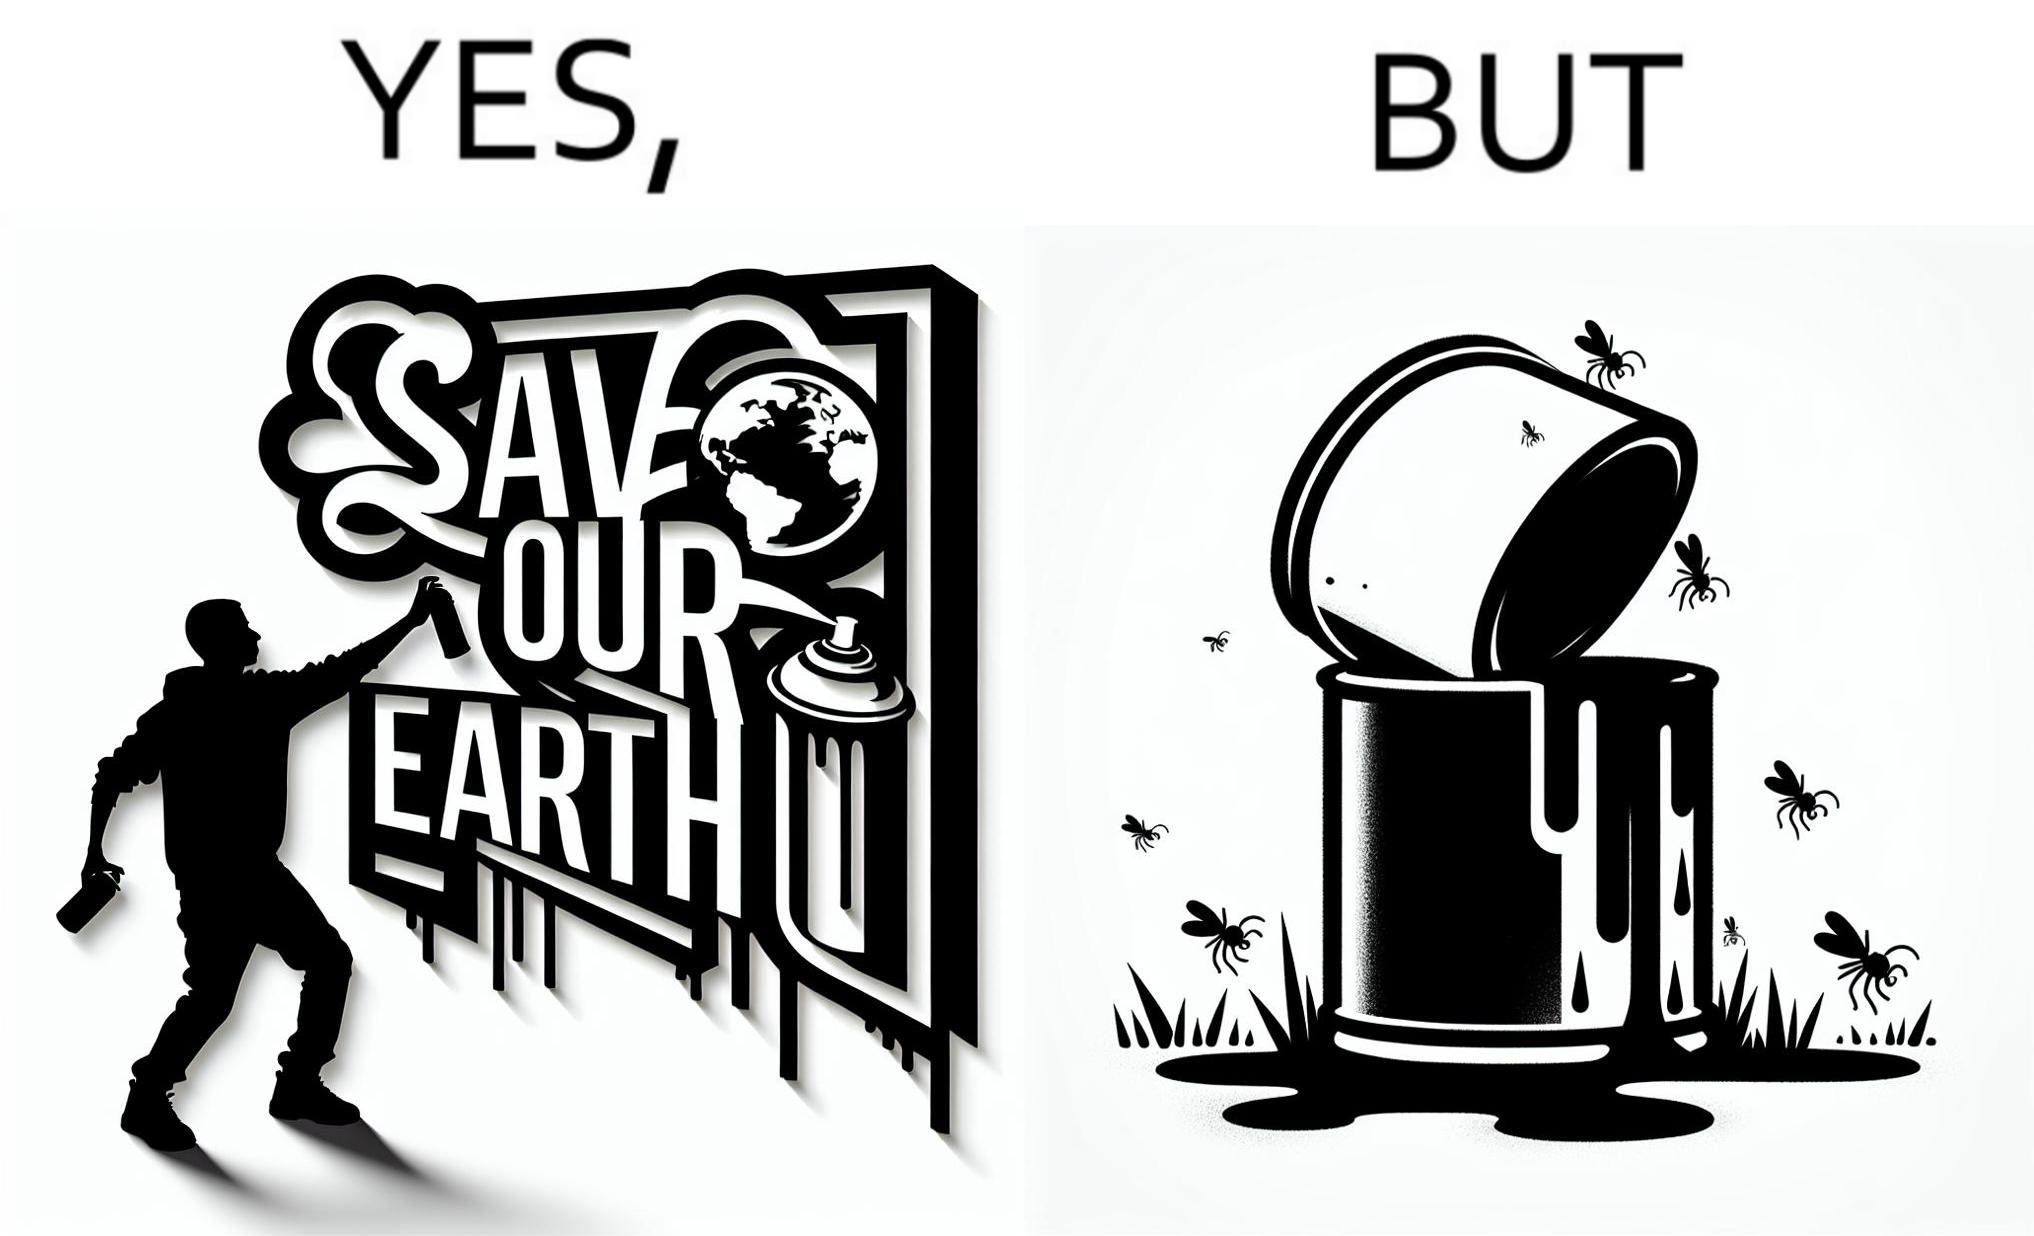What does this image depict? The image is ironical, as the cans of paint used to make graffiti on the theme "Save the Earth" seems to be destroying the Earth when it overflows on the grass, as it is harmful for the flora and fauna, as can be seen from the dying insects. 